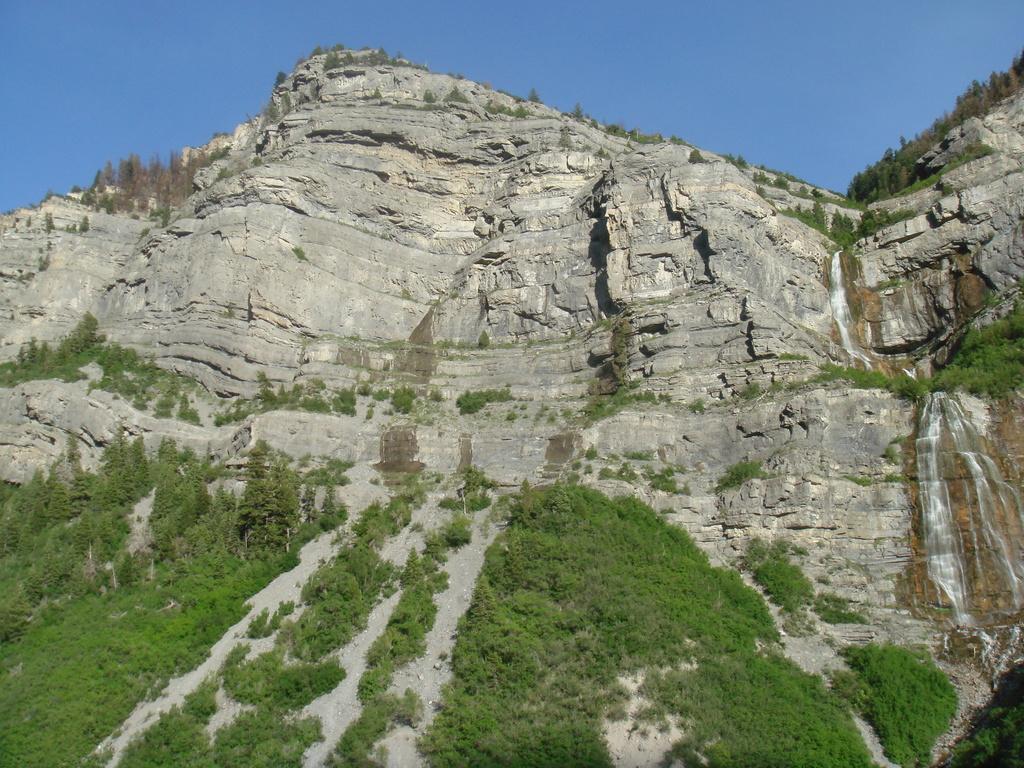In one or two sentences, can you explain what this image depicts? In this image we can see hills, waterfall, trees and sky. 